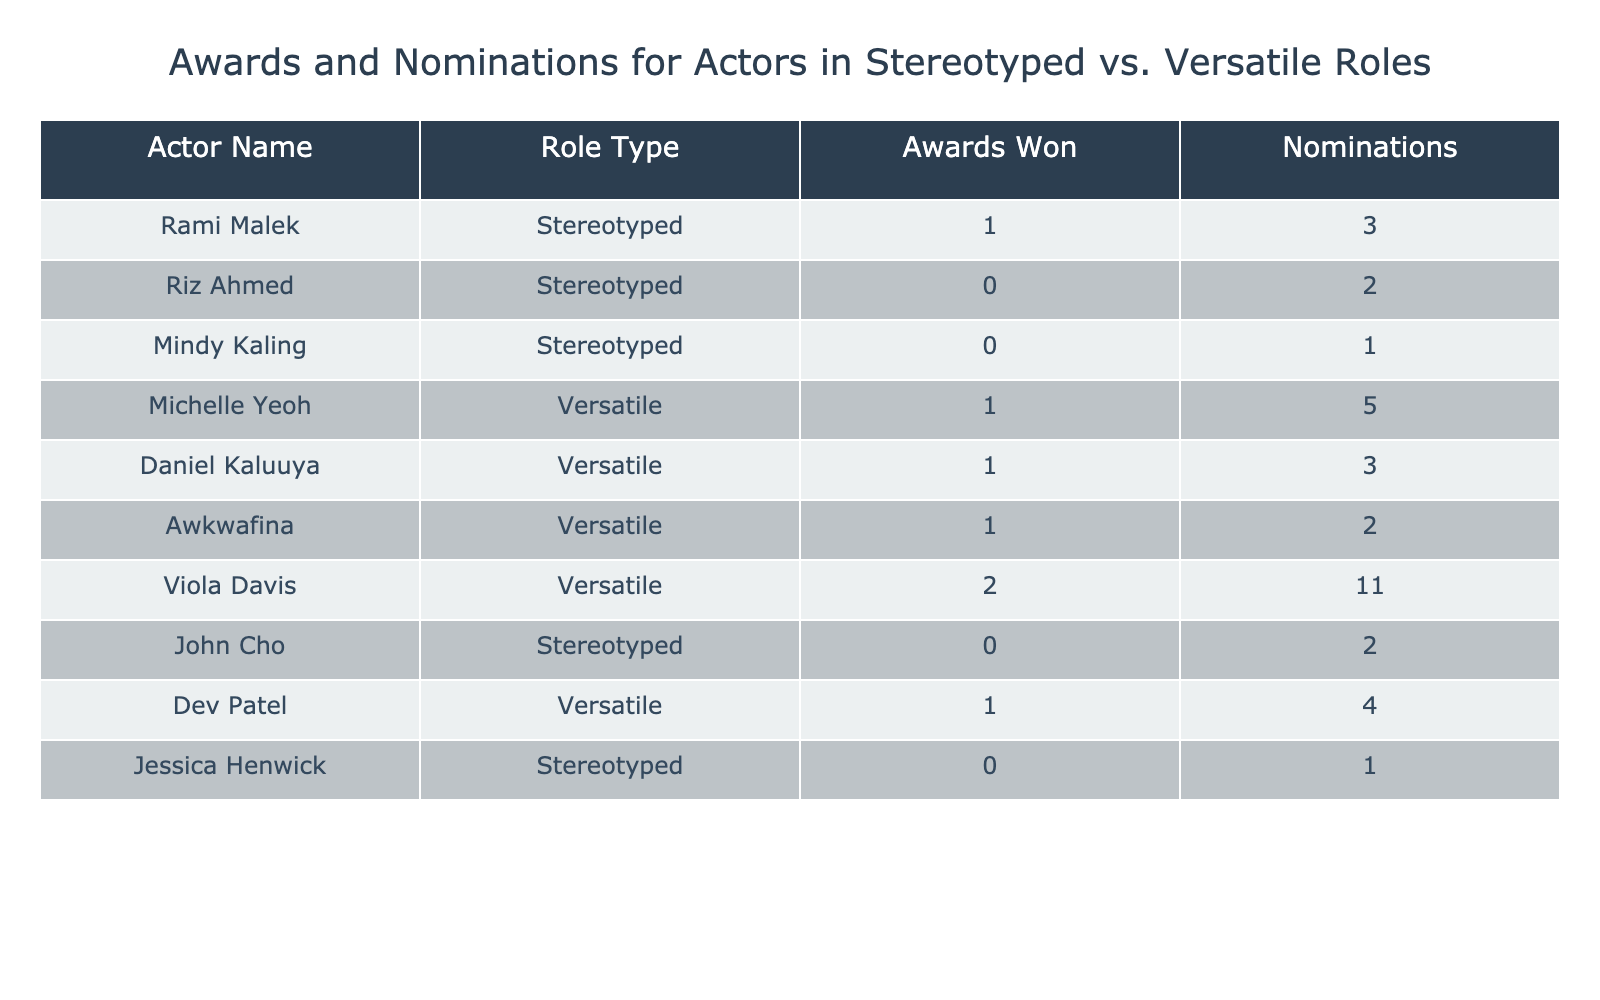What is the total number of awards won by actors in stereotyped roles? There are three actors in stereotyped roles listed in the table: Rami Malek, Riz Ahmed, and John Cho. Rami Malek has won 1 award, and the others have won 0 awards. Thus, the total is 1 + 0 + 0 = 1.
Answer: 1 What is the total number of nominations for actors in versatile roles? The actors in versatile roles are Michelle Yeoh, Daniel Kaluuya, Awkwafina, Viola Davis, and Dev Patel. Their nominations are 5, 3, 2, 11, and 4, respectively. Summing these gives: 5 + 3 + 2 + 11 + 4 = 25.
Answer: 25 Did Rami Malek receive more nominations than Riz Ahmed? Rami Malek has 3 nominations, while Riz Ahmed has 2 nominations. Since 3 is greater than 2, the statement is true.
Answer: Yes Who among the versatile actors has won the most awards? The versatile actors are Michelle Yeoh, Daniel Kaluuya, Awkwafina, Viola Davis, and Dev Patel. The awards won are 1, 1, 1, 2, and 1, respectively. Viola Davis has the highest with 2 awards.
Answer: Viola Davis What is the average number of nominations for actors in stereotyped roles? There are three actors in stereotyped roles: Rami Malek (3 nominations), Riz Ahmed (2), and John Cho (2). The total nominations is 3 + 2 + 2 = 7. Since there are 3 actors, the average is 7/3 = 2.33.
Answer: 2.33 How many actors have won awards in both role types? From the table, only Rami Malek has won 1 award in stereotyped roles, and Viola Davis has won 2 in versatile roles. Since the other actors in stereotyped roles have won none and multiple versatile roles won only one, there are no actors who have received awards in both types.
Answer: 0 What is the total number of nominations for all actors listed in the table? Adding the nominations, we get from all the actors: 3 (Malek) + 2 (Ahmed) + 1 (Kaling) + 5 (Yeoh) + 3 (Kaluuya) + 2 (Awkwafina) + 11 (Davis) + 2 (Cho) + 4 (Patel) + 1 (Henwick). The total nominations equal 3 + 2 + 1 + 5 + 3 + 2 + 11 + 2 + 4 + 1 = 34.
Answer: 34 How many versatile actors have won at least one award? From the versatile category, Michelle Yeoh, Daniel Kaluuya, Awkwafina, Viola Davis, and Dev Patel have awards of 1, 1, 1, 2, and 1 respectively. All of them won at least one award, therefore, there are 5 versatile actors with at least one award.
Answer: 5 